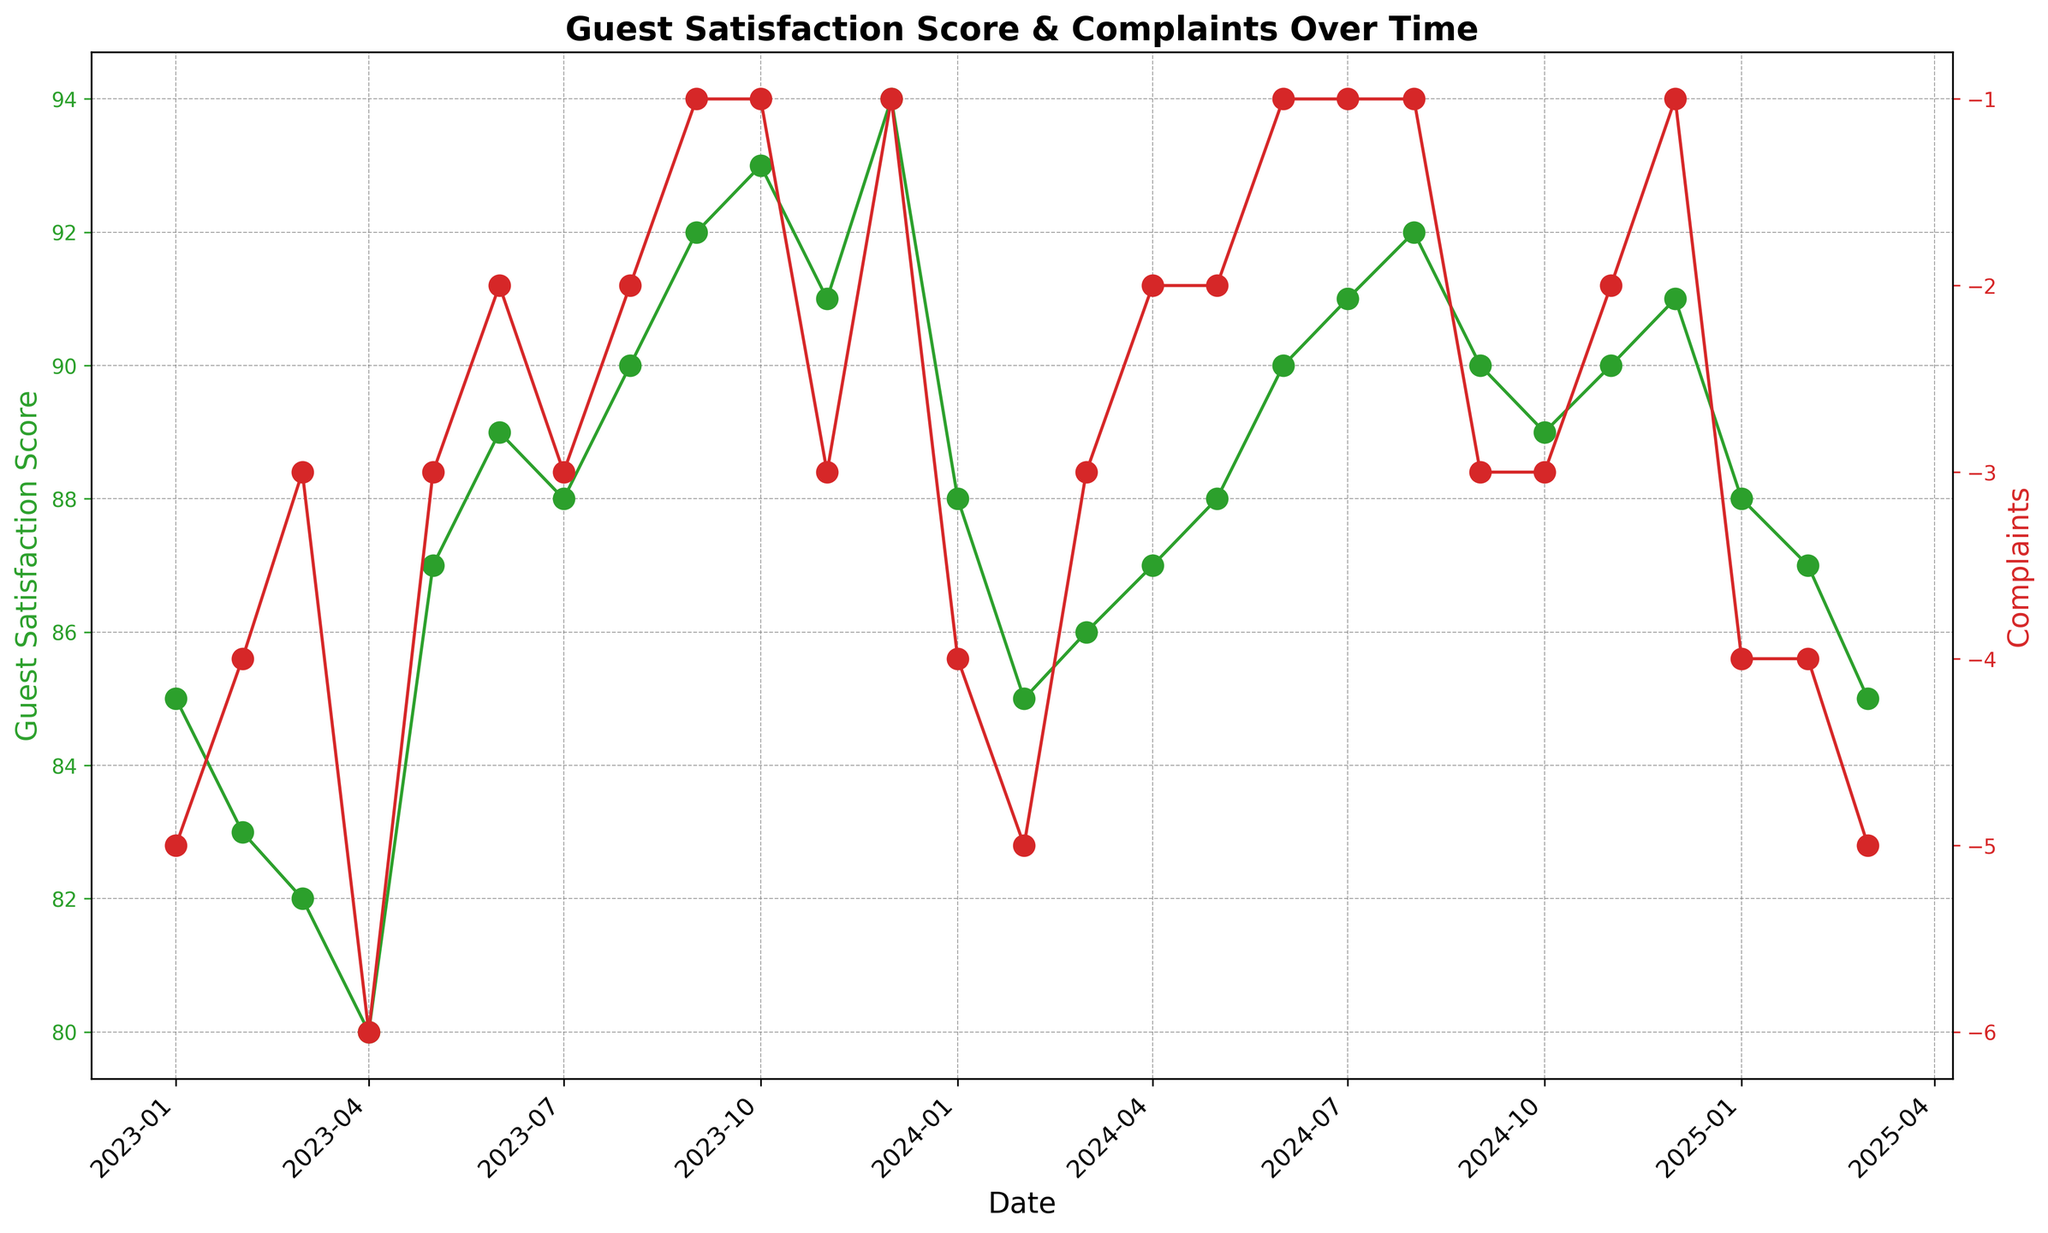What is the general trend in Guest Satisfaction Scores over the period shown? The Guest Satisfaction Score generally increases over time, starting from 85 in January 2023 and ending at 85 in March 2025, with a notable peak of 94 in December 2023
Answer: Increasing Which month has the highest Guest Satisfaction Score and what is the score? Find the highest point on the green line representing Guest Satisfaction Scores. The peak is in December 2023, where the score is 94
Answer: December 2023, 94 Compare the Complaints in January 2023 and January 2025. Which month had more complaints? Look at the red line representing Complaints. January 2023 has -5 complaints, while January 2025 has -4 complaints. Since the values are negative, -5 indicates more complaints than -4
Answer: January 2023 During which month(s) do Guest Satisfaction Scores and Complaints show the biggest positive and negative correlation? Compare the trends of both lines to check for months where high satisfaction coincides with low complaints. November 2023 has higher satisfaction at 91 and fewer complaints at -3, showing a positive correlation. April 2023 has lower satisfaction at 80 and higher complaints at -6, showing a negative correlation
Answer: April 2023, November 2023 What is the average Guest Satisfaction Score in 2024? Calculate the average of Guest Satisfaction Scores from January 2024 to December 2024. Add up the scores (88 + 85 + 86 + 87 + 88 + 90 + 91 + 92 + 90 + 89 + 90 + 91) which totals 1077, and divide by 12. The average score is 1077/12 = 89.75
Answer: 89.75 How does the change in Complaints from May 2023 to June 2023 compare to the change in Guest Satisfaction Scores in the same period? Complaints decrease from -3 to -2 (a positive change of 1 complaint), while Guest Satisfaction Scores increase from 87 to 89 (a positive change of 2 points)
Answer: Complaints: +1, Guest Satisfaction: +2 Between which two consecutive months is the increase in Guest Satisfaction Scores the highest? Check the green line for the largest upward jump between two consecutive points. The largest increase is from April 2023 to May 2023, where the score jumps from 80 to 87 (a change of +7)
Answer: April 2023 to May 2023 Are there any months where the number of complaints stayed constant for three consecutive months? Look for flat segments on the red line. The number of complaints remains at -1 from August to October in 2024
Answer: August 2024 to October 2024 